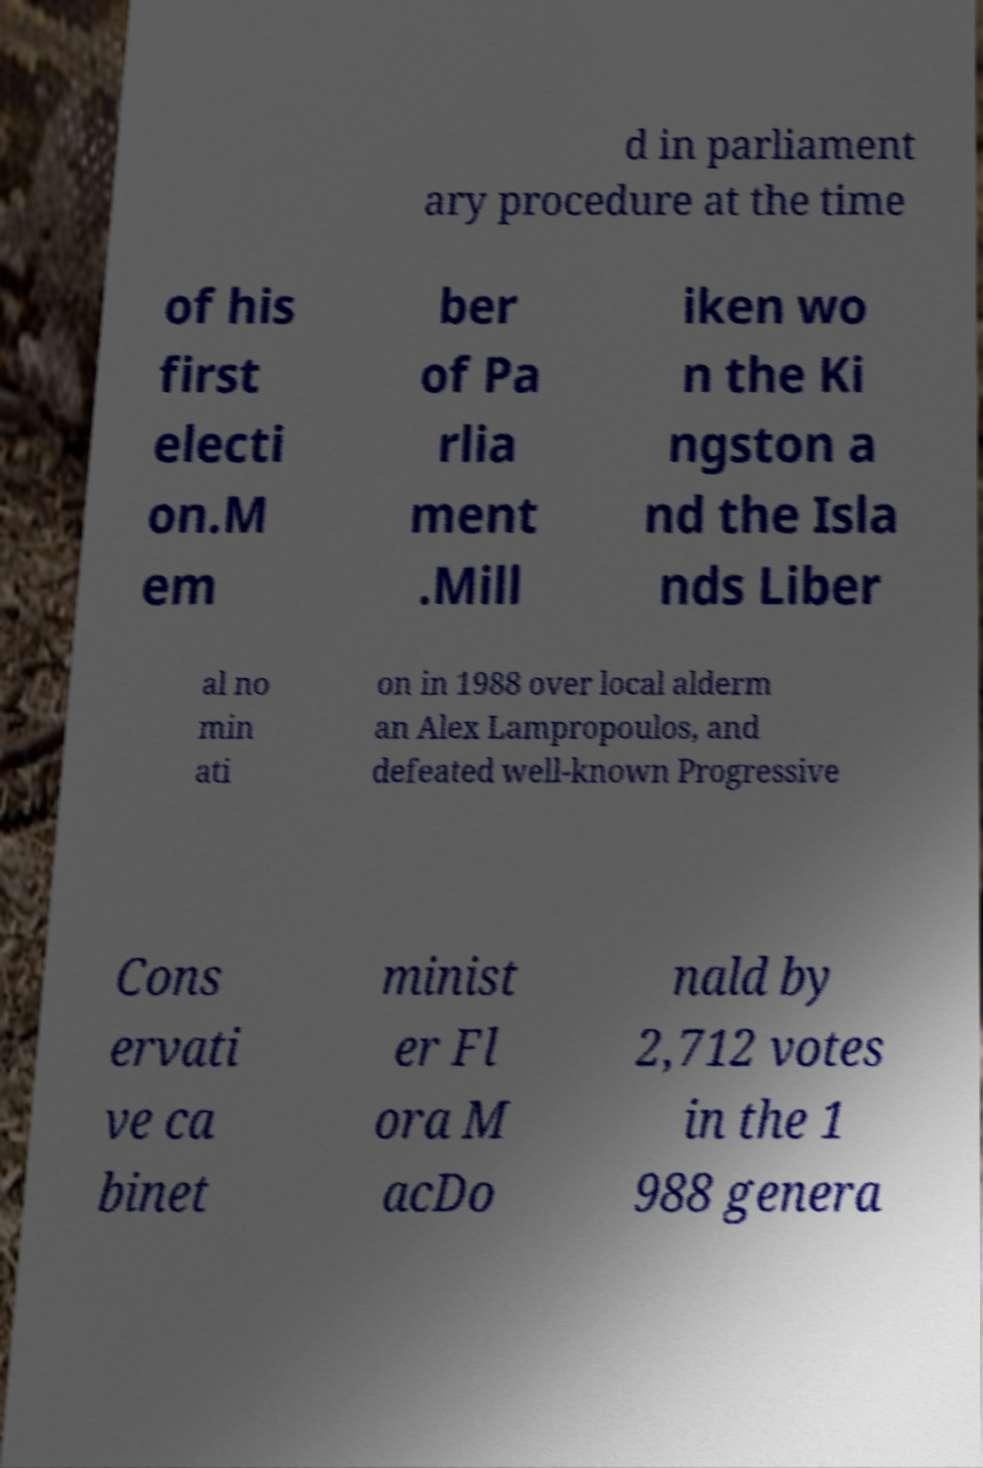What messages or text are displayed in this image? I need them in a readable, typed format. d in parliament ary procedure at the time of his first electi on.M em ber of Pa rlia ment .Mill iken wo n the Ki ngston a nd the Isla nds Liber al no min ati on in 1988 over local alderm an Alex Lampropoulos, and defeated well-known Progressive Cons ervati ve ca binet minist er Fl ora M acDo nald by 2,712 votes in the 1 988 genera 